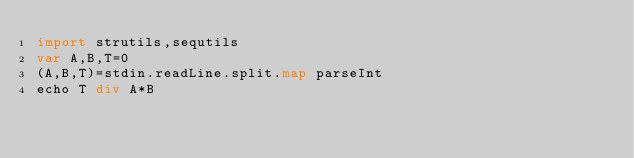Convert code to text. <code><loc_0><loc_0><loc_500><loc_500><_Nim_>import strutils,sequtils
var A,B,T=0
(A,B,T)=stdin.readLine.split.map parseInt
echo T div A*B</code> 